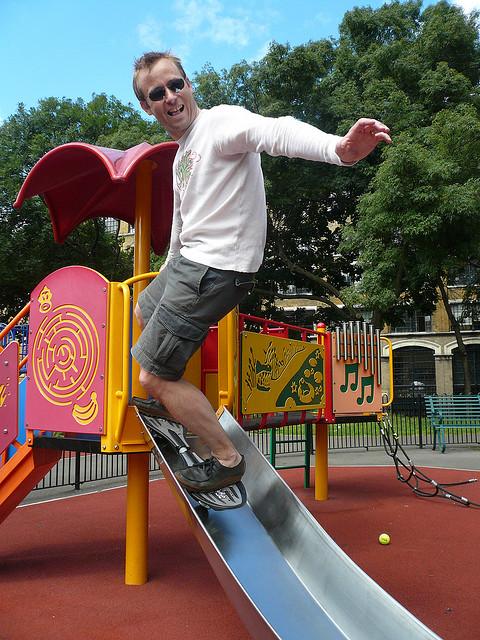Is the man skateboarding?
Keep it brief. Yes. Is the slide age appropriate for the man?
Concise answer only. No. Is he wearing sunglasses?
Be succinct. Yes. 